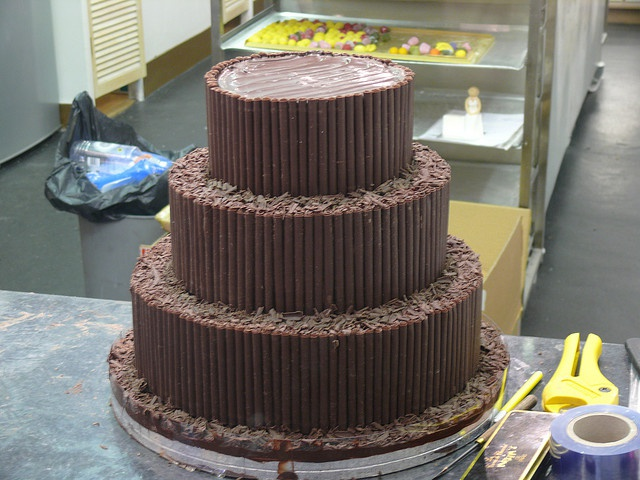Describe the objects in this image and their specific colors. I can see cake in gray, black, and darkgray tones, dining table in gray, darkgray, and lightgray tones, dining table in gray and darkgray tones, bottle in gray, lightgray, lightblue, and darkgray tones, and knife in gray, black, darkgray, and khaki tones in this image. 